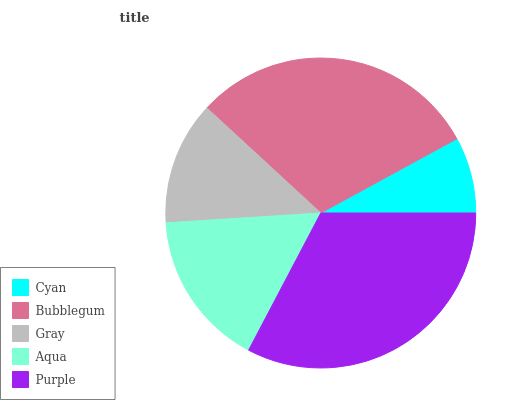Is Cyan the minimum?
Answer yes or no. Yes. Is Purple the maximum?
Answer yes or no. Yes. Is Bubblegum the minimum?
Answer yes or no. No. Is Bubblegum the maximum?
Answer yes or no. No. Is Bubblegum greater than Cyan?
Answer yes or no. Yes. Is Cyan less than Bubblegum?
Answer yes or no. Yes. Is Cyan greater than Bubblegum?
Answer yes or no. No. Is Bubblegum less than Cyan?
Answer yes or no. No. Is Aqua the high median?
Answer yes or no. Yes. Is Aqua the low median?
Answer yes or no. Yes. Is Purple the high median?
Answer yes or no. No. Is Purple the low median?
Answer yes or no. No. 